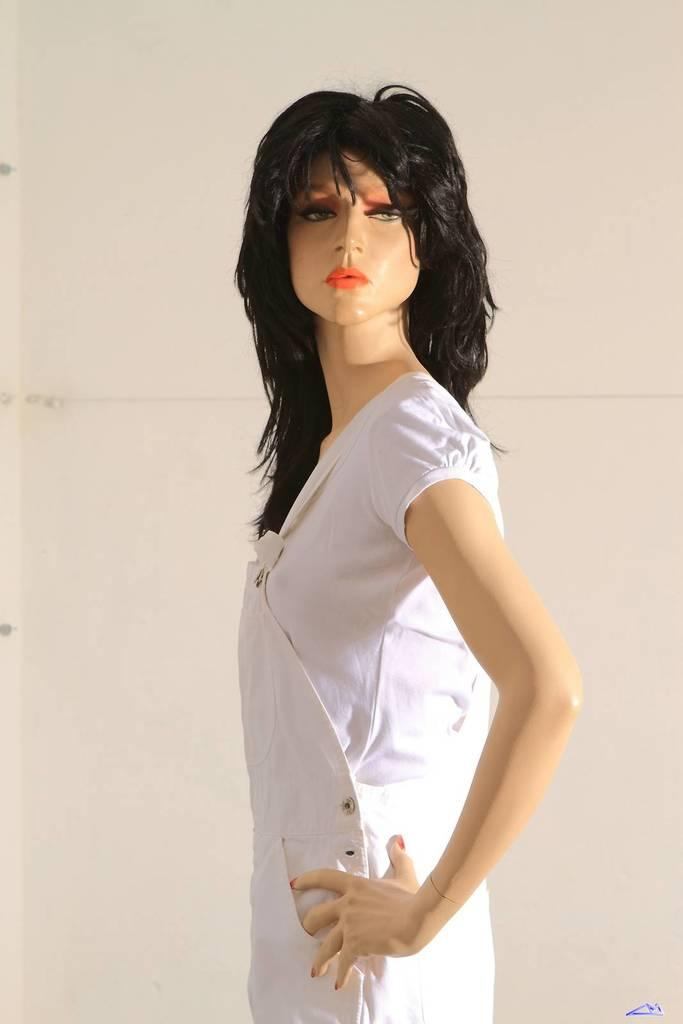What is the main subject of the image? There is a statue of a girl in the image. What is the girl in the statue wearing? The girl is wearing a white dress. What can be seen in the background of the image? There is a white color wall in the background of the image. What type of turkey can be seen in the image? There is no turkey present in the image; it features a statue of a girl wearing a white dress with a white wall in the background. 